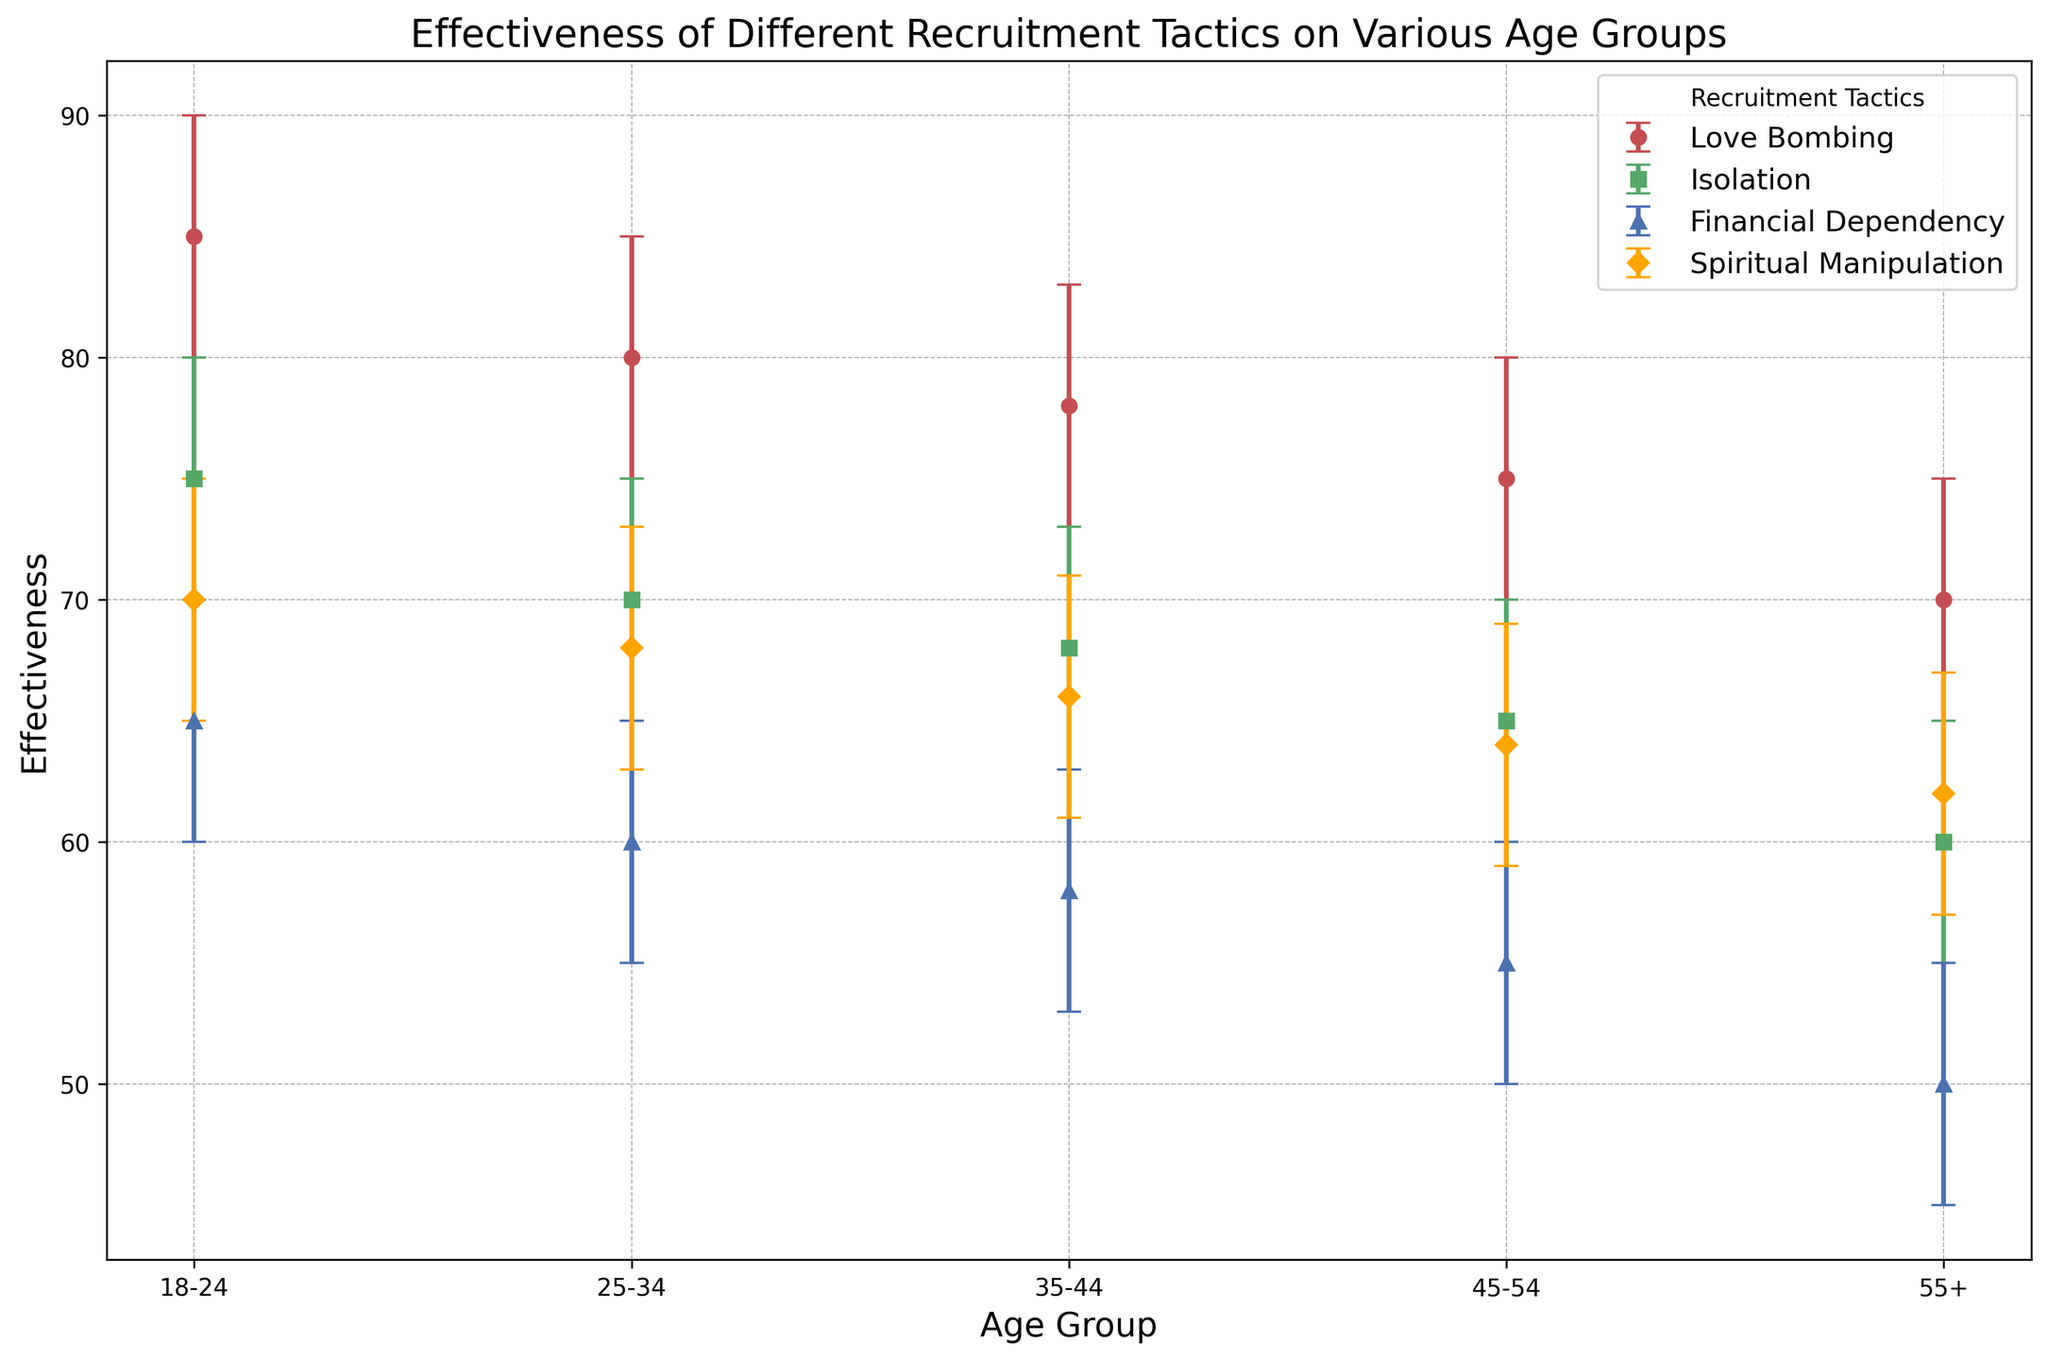What is the effectiveness of Financial Dependency in the 18-24 age group, and how does it compare to the same tactic's effectiveness in the 55+ age group? The effectiveness of Financial Dependency in the 18-24 age group is 65. In the 55+ age group, the effectiveness is 50. Comparing these, Financial Dependency is more effective in the 18-24 age group by 15 points.
Answer: 15 points Which recruitment tactic shows the highest effectiveness in individuals aged 35-44, and what is its value? Observing the figure, Love Bombing in the 35-44 age group has the highest effectiveness with a value of 78.
Answer: Love Bombing, 78 How does the confidence interval of Isolation for the 25-34 age group compare to the same tactic for the 18-24 age group? The confidence interval for Isolation in the 25-34 age group is between 65 and 75. For the 18-24 age group, it is between 70 and 80. The interval for the 18-24 group is consistently higher by 5 points compared to the 25-34 group.
Answer: 5 points higher What is the average effectiveness of Spiritual Manipulation across all age groups? The effectiveness of Spiritual Manipulation across all age groups is 70, 68, 66, 64, and 62, respectively. Summing these and dividing by the number of age groups: (70 + 68 + 66 + 64 + 62) / 5 = 66.
Answer: 66 Which age group exhibits the largest confidence interval range for any recruitment tactic, and what is this range? By inspecting the chart, the 18-24 age group shows the largest range for Love Bombing with an interval from 80 to 90, resulting in a range of 10.
Answer: 10 points What is the difference in effectiveness between Love Bombing and Financial Dependency in the 25-34 age group? In the 25-34 age group, the effectiveness of Love Bombing is 80, and Financial Dependency is 60. Thus, the difference is 80 - 60 = 20.
Answer: 20 points Does Isolation have a higher effectiveness than Spiritual Manipulation in the 45-54 age group, and if so, by how much? In the 45-54 age group, Isolation has an effectiveness of 65, and Spiritual Manipulation has 64. Isolation is higher by 1 point.
Answer: 1 point higher Which recruitment tactic shows the highest variability (largest confidence interval range) across all age groups, and in which age group does it occur? Reviewing the confidence intervals, Love Bombing in the 18-24 age group shows the highest variability with a range of 10 (from 80 to 90).
Answer: Love Bombing, 18-24 age group Which age group and recruitment tactic combination exhibits the lowest effectiveness, and what is the value? Observing the chart, Financial Dependency in the 55+ age group has the lowest effectiveness with a value of 50.
Answer: Financial Dependency, 55+, 50 